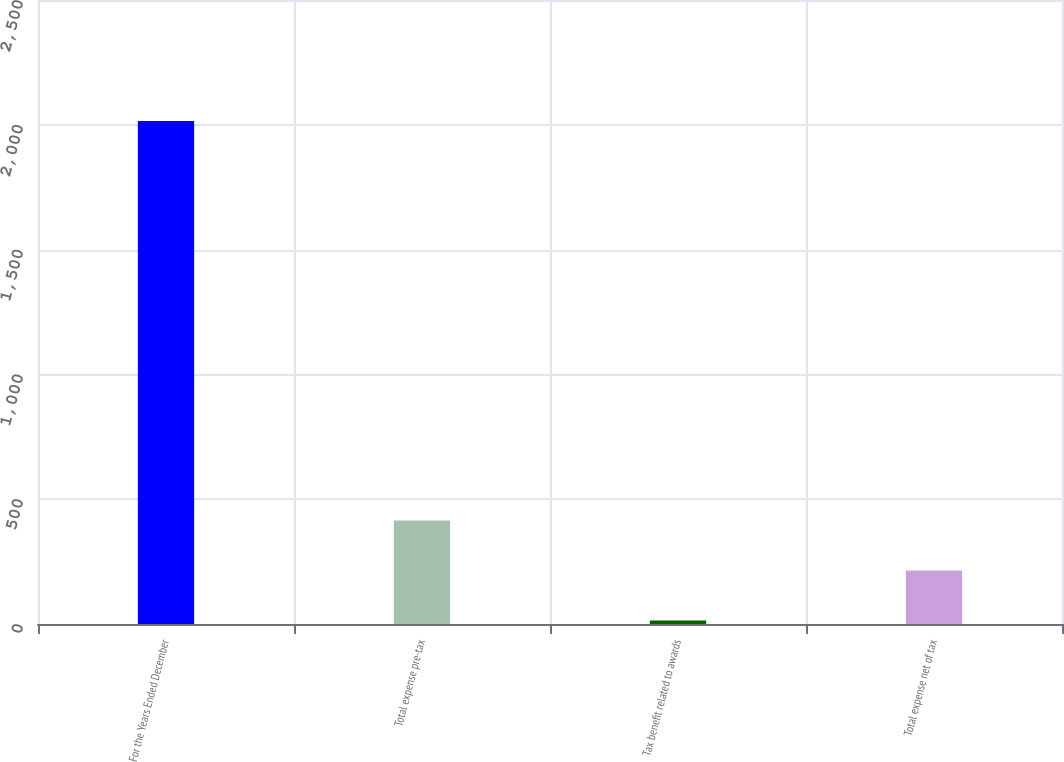Convert chart. <chart><loc_0><loc_0><loc_500><loc_500><bar_chart><fcel>For the Years Ended December<fcel>Total expense pre-tax<fcel>Tax benefit related to awards<fcel>Total expense net of tax<nl><fcel>2015<fcel>414.6<fcel>14.5<fcel>214.55<nl></chart> 